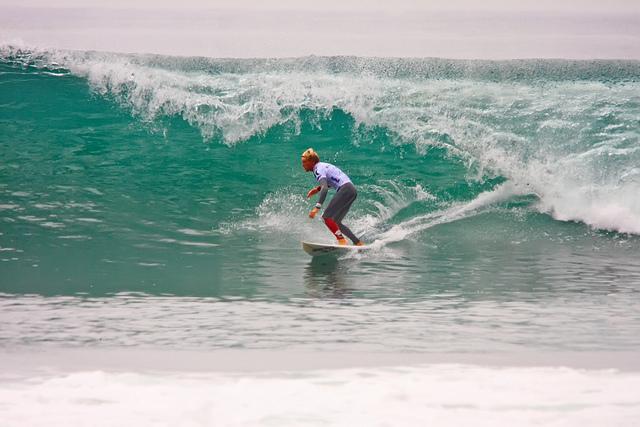What color are the wetsuits?
Give a very brief answer. Blue. Is this water dangerous?
Be succinct. Yes. What is the man doing?
Keep it brief. Surfing. Are there big waves to ride?
Short answer required. Yes. Is the man moving?
Short answer required. Yes. What color shirt is the man wearing?
Short answer required. White. Is the person wearing a shirt?
Keep it brief. Yes. 